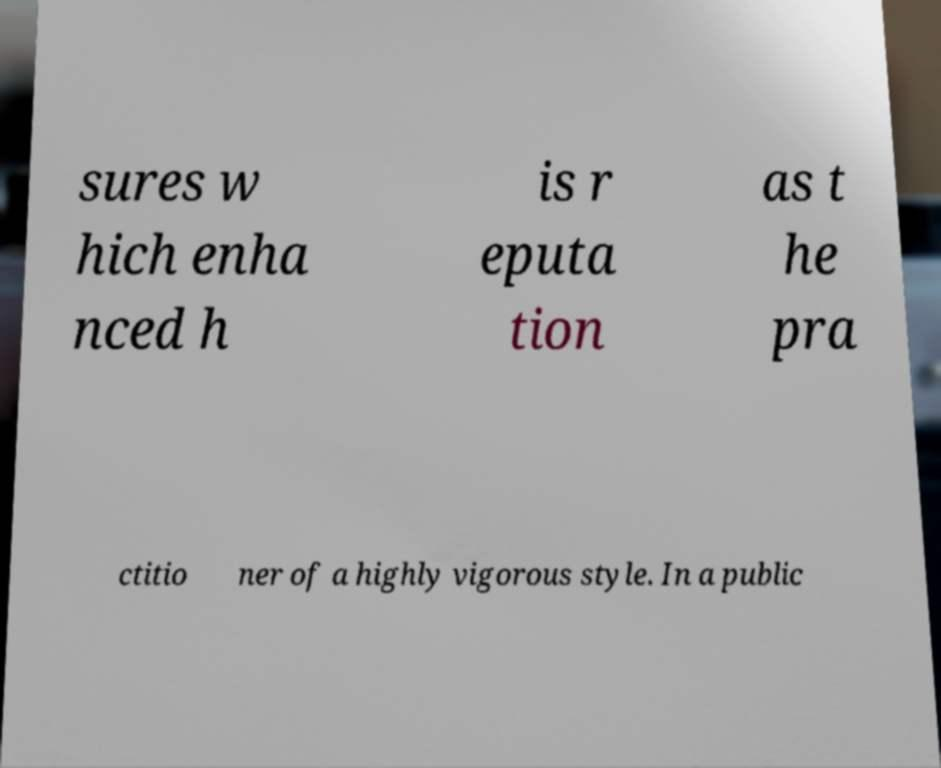I need the written content from this picture converted into text. Can you do that? sures w hich enha nced h is r eputa tion as t he pra ctitio ner of a highly vigorous style. In a public 